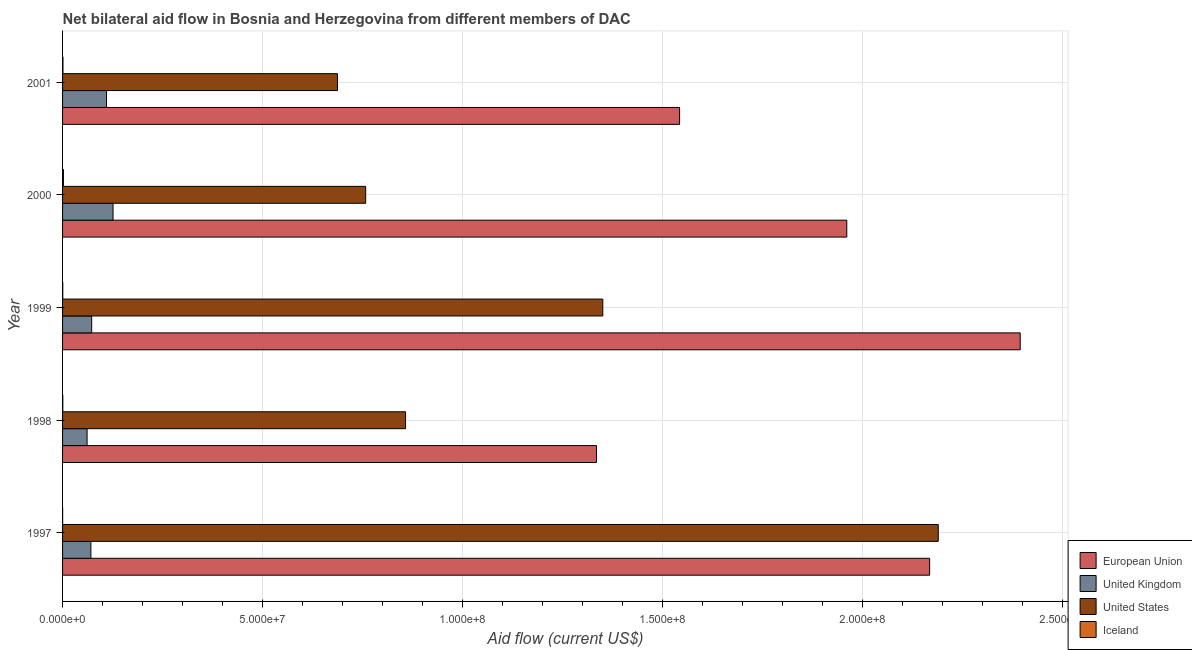How many different coloured bars are there?
Provide a short and direct response. 4. Are the number of bars per tick equal to the number of legend labels?
Offer a very short reply. Yes. Are the number of bars on each tick of the Y-axis equal?
Your response must be concise. Yes. How many bars are there on the 2nd tick from the top?
Provide a short and direct response. 4. How many bars are there on the 5th tick from the bottom?
Give a very brief answer. 4. In how many cases, is the number of bars for a given year not equal to the number of legend labels?
Ensure brevity in your answer.  0. What is the amount of aid given by eu in 1998?
Your answer should be compact. 1.33e+08. Across all years, what is the maximum amount of aid given by eu?
Keep it short and to the point. 2.39e+08. Across all years, what is the minimum amount of aid given by us?
Make the answer very short. 6.87e+07. What is the total amount of aid given by eu in the graph?
Offer a terse response. 9.40e+08. What is the difference between the amount of aid given by iceland in 1998 and that in 2000?
Ensure brevity in your answer.  -1.60e+05. What is the difference between the amount of aid given by eu in 2000 and the amount of aid given by uk in 1998?
Offer a very short reply. 1.90e+08. What is the average amount of aid given by us per year?
Your answer should be compact. 1.17e+08. In the year 1999, what is the difference between the amount of aid given by iceland and amount of aid given by eu?
Offer a terse response. -2.39e+08. What is the ratio of the amount of aid given by uk in 1999 to that in 2001?
Offer a very short reply. 0.66. Is the amount of aid given by uk in 1999 less than that in 2000?
Ensure brevity in your answer.  Yes. Is the difference between the amount of aid given by iceland in 1999 and 2000 greater than the difference between the amount of aid given by us in 1999 and 2000?
Your answer should be very brief. No. What is the difference between the highest and the lowest amount of aid given by eu?
Your answer should be compact. 1.06e+08. In how many years, is the amount of aid given by uk greater than the average amount of aid given by uk taken over all years?
Provide a succinct answer. 2. Is the sum of the amount of aid given by us in 1997 and 2001 greater than the maximum amount of aid given by uk across all years?
Offer a terse response. Yes. What does the 3rd bar from the top in 1999 represents?
Provide a short and direct response. United Kingdom. What does the 1st bar from the bottom in 1999 represents?
Provide a short and direct response. European Union. Is it the case that in every year, the sum of the amount of aid given by eu and amount of aid given by uk is greater than the amount of aid given by us?
Offer a terse response. Yes. Are all the bars in the graph horizontal?
Keep it short and to the point. Yes. Where does the legend appear in the graph?
Offer a terse response. Bottom right. How many legend labels are there?
Offer a terse response. 4. What is the title of the graph?
Your response must be concise. Net bilateral aid flow in Bosnia and Herzegovina from different members of DAC. What is the label or title of the X-axis?
Offer a very short reply. Aid flow (current US$). What is the label or title of the Y-axis?
Give a very brief answer. Year. What is the Aid flow (current US$) of European Union in 1997?
Your response must be concise. 2.17e+08. What is the Aid flow (current US$) in United Kingdom in 1997?
Make the answer very short. 7.08e+06. What is the Aid flow (current US$) in United States in 1997?
Provide a short and direct response. 2.19e+08. What is the Aid flow (current US$) of European Union in 1998?
Provide a short and direct response. 1.33e+08. What is the Aid flow (current US$) of United Kingdom in 1998?
Provide a short and direct response. 6.13e+06. What is the Aid flow (current US$) in United States in 1998?
Your answer should be very brief. 8.58e+07. What is the Aid flow (current US$) in Iceland in 1998?
Provide a short and direct response. 6.00e+04. What is the Aid flow (current US$) of European Union in 1999?
Your response must be concise. 2.39e+08. What is the Aid flow (current US$) of United Kingdom in 1999?
Your answer should be compact. 7.28e+06. What is the Aid flow (current US$) of United States in 1999?
Offer a very short reply. 1.35e+08. What is the Aid flow (current US$) of Iceland in 1999?
Offer a very short reply. 5.00e+04. What is the Aid flow (current US$) in European Union in 2000?
Ensure brevity in your answer.  1.96e+08. What is the Aid flow (current US$) in United Kingdom in 2000?
Make the answer very short. 1.26e+07. What is the Aid flow (current US$) in United States in 2000?
Offer a terse response. 7.58e+07. What is the Aid flow (current US$) of Iceland in 2000?
Give a very brief answer. 2.20e+05. What is the Aid flow (current US$) in European Union in 2001?
Make the answer very short. 1.54e+08. What is the Aid flow (current US$) in United Kingdom in 2001?
Keep it short and to the point. 1.10e+07. What is the Aid flow (current US$) in United States in 2001?
Offer a terse response. 6.87e+07. What is the Aid flow (current US$) of Iceland in 2001?
Provide a succinct answer. 1.00e+05. Across all years, what is the maximum Aid flow (current US$) of European Union?
Provide a succinct answer. 2.39e+08. Across all years, what is the maximum Aid flow (current US$) in United Kingdom?
Make the answer very short. 1.26e+07. Across all years, what is the maximum Aid flow (current US$) in United States?
Offer a terse response. 2.19e+08. Across all years, what is the maximum Aid flow (current US$) in Iceland?
Ensure brevity in your answer.  2.20e+05. Across all years, what is the minimum Aid flow (current US$) of European Union?
Your answer should be compact. 1.33e+08. Across all years, what is the minimum Aid flow (current US$) in United Kingdom?
Make the answer very short. 6.13e+06. Across all years, what is the minimum Aid flow (current US$) of United States?
Your answer should be compact. 6.87e+07. What is the total Aid flow (current US$) in European Union in the graph?
Your response must be concise. 9.40e+08. What is the total Aid flow (current US$) of United Kingdom in the graph?
Offer a terse response. 4.41e+07. What is the total Aid flow (current US$) in United States in the graph?
Provide a succinct answer. 5.84e+08. What is the total Aid flow (current US$) of Iceland in the graph?
Provide a succinct answer. 4.50e+05. What is the difference between the Aid flow (current US$) in European Union in 1997 and that in 1998?
Your answer should be very brief. 8.33e+07. What is the difference between the Aid flow (current US$) in United Kingdom in 1997 and that in 1998?
Ensure brevity in your answer.  9.50e+05. What is the difference between the Aid flow (current US$) in United States in 1997 and that in 1998?
Ensure brevity in your answer.  1.33e+08. What is the difference between the Aid flow (current US$) of Iceland in 1997 and that in 1998?
Give a very brief answer. -4.00e+04. What is the difference between the Aid flow (current US$) of European Union in 1997 and that in 1999?
Your response must be concise. -2.26e+07. What is the difference between the Aid flow (current US$) of United Kingdom in 1997 and that in 1999?
Your response must be concise. -2.00e+05. What is the difference between the Aid flow (current US$) in United States in 1997 and that in 1999?
Offer a very short reply. 8.39e+07. What is the difference between the Aid flow (current US$) of Iceland in 1997 and that in 1999?
Your answer should be very brief. -3.00e+04. What is the difference between the Aid flow (current US$) of European Union in 1997 and that in 2000?
Your answer should be very brief. 2.07e+07. What is the difference between the Aid flow (current US$) of United Kingdom in 1997 and that in 2000?
Ensure brevity in your answer.  -5.54e+06. What is the difference between the Aid flow (current US$) in United States in 1997 and that in 2000?
Give a very brief answer. 1.43e+08. What is the difference between the Aid flow (current US$) of European Union in 1997 and that in 2001?
Ensure brevity in your answer.  6.25e+07. What is the difference between the Aid flow (current US$) in United Kingdom in 1997 and that in 2001?
Give a very brief answer. -3.90e+06. What is the difference between the Aid flow (current US$) in United States in 1997 and that in 2001?
Keep it short and to the point. 1.50e+08. What is the difference between the Aid flow (current US$) of European Union in 1998 and that in 1999?
Provide a succinct answer. -1.06e+08. What is the difference between the Aid flow (current US$) of United Kingdom in 1998 and that in 1999?
Your answer should be very brief. -1.15e+06. What is the difference between the Aid flow (current US$) in United States in 1998 and that in 1999?
Offer a very short reply. -4.93e+07. What is the difference between the Aid flow (current US$) of European Union in 1998 and that in 2000?
Ensure brevity in your answer.  -6.26e+07. What is the difference between the Aid flow (current US$) in United Kingdom in 1998 and that in 2000?
Ensure brevity in your answer.  -6.49e+06. What is the difference between the Aid flow (current US$) of United States in 1998 and that in 2000?
Provide a succinct answer. 9.97e+06. What is the difference between the Aid flow (current US$) in Iceland in 1998 and that in 2000?
Your response must be concise. -1.60e+05. What is the difference between the Aid flow (current US$) in European Union in 1998 and that in 2001?
Make the answer very short. -2.08e+07. What is the difference between the Aid flow (current US$) in United Kingdom in 1998 and that in 2001?
Your response must be concise. -4.85e+06. What is the difference between the Aid flow (current US$) in United States in 1998 and that in 2001?
Give a very brief answer. 1.70e+07. What is the difference between the Aid flow (current US$) of European Union in 1999 and that in 2000?
Ensure brevity in your answer.  4.34e+07. What is the difference between the Aid flow (current US$) of United Kingdom in 1999 and that in 2000?
Ensure brevity in your answer.  -5.34e+06. What is the difference between the Aid flow (current US$) of United States in 1999 and that in 2000?
Offer a very short reply. 5.93e+07. What is the difference between the Aid flow (current US$) in Iceland in 1999 and that in 2000?
Your answer should be very brief. -1.70e+05. What is the difference between the Aid flow (current US$) in European Union in 1999 and that in 2001?
Provide a short and direct response. 8.52e+07. What is the difference between the Aid flow (current US$) in United Kingdom in 1999 and that in 2001?
Provide a short and direct response. -3.70e+06. What is the difference between the Aid flow (current US$) of United States in 1999 and that in 2001?
Provide a short and direct response. 6.63e+07. What is the difference between the Aid flow (current US$) in European Union in 2000 and that in 2001?
Offer a very short reply. 4.18e+07. What is the difference between the Aid flow (current US$) in United Kingdom in 2000 and that in 2001?
Provide a short and direct response. 1.64e+06. What is the difference between the Aid flow (current US$) in United States in 2000 and that in 2001?
Offer a terse response. 7.04e+06. What is the difference between the Aid flow (current US$) in European Union in 1997 and the Aid flow (current US$) in United Kingdom in 1998?
Your response must be concise. 2.11e+08. What is the difference between the Aid flow (current US$) in European Union in 1997 and the Aid flow (current US$) in United States in 1998?
Your response must be concise. 1.31e+08. What is the difference between the Aid flow (current US$) of European Union in 1997 and the Aid flow (current US$) of Iceland in 1998?
Offer a very short reply. 2.17e+08. What is the difference between the Aid flow (current US$) of United Kingdom in 1997 and the Aid flow (current US$) of United States in 1998?
Ensure brevity in your answer.  -7.87e+07. What is the difference between the Aid flow (current US$) of United Kingdom in 1997 and the Aid flow (current US$) of Iceland in 1998?
Your answer should be very brief. 7.02e+06. What is the difference between the Aid flow (current US$) of United States in 1997 and the Aid flow (current US$) of Iceland in 1998?
Offer a terse response. 2.19e+08. What is the difference between the Aid flow (current US$) of European Union in 1997 and the Aid flow (current US$) of United Kingdom in 1999?
Make the answer very short. 2.09e+08. What is the difference between the Aid flow (current US$) of European Union in 1997 and the Aid flow (current US$) of United States in 1999?
Offer a very short reply. 8.17e+07. What is the difference between the Aid flow (current US$) of European Union in 1997 and the Aid flow (current US$) of Iceland in 1999?
Ensure brevity in your answer.  2.17e+08. What is the difference between the Aid flow (current US$) of United Kingdom in 1997 and the Aid flow (current US$) of United States in 1999?
Your answer should be compact. -1.28e+08. What is the difference between the Aid flow (current US$) of United Kingdom in 1997 and the Aid flow (current US$) of Iceland in 1999?
Your response must be concise. 7.03e+06. What is the difference between the Aid flow (current US$) of United States in 1997 and the Aid flow (current US$) of Iceland in 1999?
Provide a short and direct response. 2.19e+08. What is the difference between the Aid flow (current US$) in European Union in 1997 and the Aid flow (current US$) in United Kingdom in 2000?
Offer a terse response. 2.04e+08. What is the difference between the Aid flow (current US$) in European Union in 1997 and the Aid flow (current US$) in United States in 2000?
Your answer should be very brief. 1.41e+08. What is the difference between the Aid flow (current US$) of European Union in 1997 and the Aid flow (current US$) of Iceland in 2000?
Provide a short and direct response. 2.17e+08. What is the difference between the Aid flow (current US$) of United Kingdom in 1997 and the Aid flow (current US$) of United States in 2000?
Make the answer very short. -6.87e+07. What is the difference between the Aid flow (current US$) in United Kingdom in 1997 and the Aid flow (current US$) in Iceland in 2000?
Provide a succinct answer. 6.86e+06. What is the difference between the Aid flow (current US$) in United States in 1997 and the Aid flow (current US$) in Iceland in 2000?
Provide a succinct answer. 2.19e+08. What is the difference between the Aid flow (current US$) in European Union in 1997 and the Aid flow (current US$) in United Kingdom in 2001?
Provide a short and direct response. 2.06e+08. What is the difference between the Aid flow (current US$) in European Union in 1997 and the Aid flow (current US$) in United States in 2001?
Provide a short and direct response. 1.48e+08. What is the difference between the Aid flow (current US$) in European Union in 1997 and the Aid flow (current US$) in Iceland in 2001?
Offer a terse response. 2.17e+08. What is the difference between the Aid flow (current US$) in United Kingdom in 1997 and the Aid flow (current US$) in United States in 2001?
Ensure brevity in your answer.  -6.17e+07. What is the difference between the Aid flow (current US$) of United Kingdom in 1997 and the Aid flow (current US$) of Iceland in 2001?
Your answer should be very brief. 6.98e+06. What is the difference between the Aid flow (current US$) in United States in 1997 and the Aid flow (current US$) in Iceland in 2001?
Give a very brief answer. 2.19e+08. What is the difference between the Aid flow (current US$) of European Union in 1998 and the Aid flow (current US$) of United Kingdom in 1999?
Give a very brief answer. 1.26e+08. What is the difference between the Aid flow (current US$) in European Union in 1998 and the Aid flow (current US$) in United States in 1999?
Provide a succinct answer. -1.57e+06. What is the difference between the Aid flow (current US$) of European Union in 1998 and the Aid flow (current US$) of Iceland in 1999?
Make the answer very short. 1.33e+08. What is the difference between the Aid flow (current US$) of United Kingdom in 1998 and the Aid flow (current US$) of United States in 1999?
Offer a very short reply. -1.29e+08. What is the difference between the Aid flow (current US$) of United Kingdom in 1998 and the Aid flow (current US$) of Iceland in 1999?
Your answer should be compact. 6.08e+06. What is the difference between the Aid flow (current US$) of United States in 1998 and the Aid flow (current US$) of Iceland in 1999?
Give a very brief answer. 8.57e+07. What is the difference between the Aid flow (current US$) in European Union in 1998 and the Aid flow (current US$) in United Kingdom in 2000?
Give a very brief answer. 1.21e+08. What is the difference between the Aid flow (current US$) of European Union in 1998 and the Aid flow (current US$) of United States in 2000?
Make the answer very short. 5.77e+07. What is the difference between the Aid flow (current US$) of European Union in 1998 and the Aid flow (current US$) of Iceland in 2000?
Offer a terse response. 1.33e+08. What is the difference between the Aid flow (current US$) of United Kingdom in 1998 and the Aid flow (current US$) of United States in 2000?
Make the answer very short. -6.96e+07. What is the difference between the Aid flow (current US$) in United Kingdom in 1998 and the Aid flow (current US$) in Iceland in 2000?
Your response must be concise. 5.91e+06. What is the difference between the Aid flow (current US$) of United States in 1998 and the Aid flow (current US$) of Iceland in 2000?
Give a very brief answer. 8.55e+07. What is the difference between the Aid flow (current US$) in European Union in 1998 and the Aid flow (current US$) in United Kingdom in 2001?
Provide a short and direct response. 1.23e+08. What is the difference between the Aid flow (current US$) in European Union in 1998 and the Aid flow (current US$) in United States in 2001?
Your answer should be very brief. 6.48e+07. What is the difference between the Aid flow (current US$) in European Union in 1998 and the Aid flow (current US$) in Iceland in 2001?
Your answer should be compact. 1.33e+08. What is the difference between the Aid flow (current US$) in United Kingdom in 1998 and the Aid flow (current US$) in United States in 2001?
Your answer should be very brief. -6.26e+07. What is the difference between the Aid flow (current US$) of United Kingdom in 1998 and the Aid flow (current US$) of Iceland in 2001?
Your answer should be compact. 6.03e+06. What is the difference between the Aid flow (current US$) of United States in 1998 and the Aid flow (current US$) of Iceland in 2001?
Keep it short and to the point. 8.56e+07. What is the difference between the Aid flow (current US$) in European Union in 1999 and the Aid flow (current US$) in United Kingdom in 2000?
Keep it short and to the point. 2.27e+08. What is the difference between the Aid flow (current US$) in European Union in 1999 and the Aid flow (current US$) in United States in 2000?
Your answer should be very brief. 1.64e+08. What is the difference between the Aid flow (current US$) in European Union in 1999 and the Aid flow (current US$) in Iceland in 2000?
Provide a succinct answer. 2.39e+08. What is the difference between the Aid flow (current US$) in United Kingdom in 1999 and the Aid flow (current US$) in United States in 2000?
Keep it short and to the point. -6.85e+07. What is the difference between the Aid flow (current US$) in United Kingdom in 1999 and the Aid flow (current US$) in Iceland in 2000?
Offer a terse response. 7.06e+06. What is the difference between the Aid flow (current US$) in United States in 1999 and the Aid flow (current US$) in Iceland in 2000?
Your answer should be very brief. 1.35e+08. What is the difference between the Aid flow (current US$) of European Union in 1999 and the Aid flow (current US$) of United Kingdom in 2001?
Your answer should be compact. 2.28e+08. What is the difference between the Aid flow (current US$) in European Union in 1999 and the Aid flow (current US$) in United States in 2001?
Ensure brevity in your answer.  1.71e+08. What is the difference between the Aid flow (current US$) in European Union in 1999 and the Aid flow (current US$) in Iceland in 2001?
Ensure brevity in your answer.  2.39e+08. What is the difference between the Aid flow (current US$) in United Kingdom in 1999 and the Aid flow (current US$) in United States in 2001?
Keep it short and to the point. -6.15e+07. What is the difference between the Aid flow (current US$) of United Kingdom in 1999 and the Aid flow (current US$) of Iceland in 2001?
Your response must be concise. 7.18e+06. What is the difference between the Aid flow (current US$) of United States in 1999 and the Aid flow (current US$) of Iceland in 2001?
Give a very brief answer. 1.35e+08. What is the difference between the Aid flow (current US$) in European Union in 2000 and the Aid flow (current US$) in United Kingdom in 2001?
Your answer should be compact. 1.85e+08. What is the difference between the Aid flow (current US$) of European Union in 2000 and the Aid flow (current US$) of United States in 2001?
Your answer should be compact. 1.27e+08. What is the difference between the Aid flow (current US$) in European Union in 2000 and the Aid flow (current US$) in Iceland in 2001?
Give a very brief answer. 1.96e+08. What is the difference between the Aid flow (current US$) in United Kingdom in 2000 and the Aid flow (current US$) in United States in 2001?
Offer a very short reply. -5.61e+07. What is the difference between the Aid flow (current US$) in United Kingdom in 2000 and the Aid flow (current US$) in Iceland in 2001?
Provide a short and direct response. 1.25e+07. What is the difference between the Aid flow (current US$) of United States in 2000 and the Aid flow (current US$) of Iceland in 2001?
Your response must be concise. 7.57e+07. What is the average Aid flow (current US$) in European Union per year?
Your answer should be very brief. 1.88e+08. What is the average Aid flow (current US$) in United Kingdom per year?
Keep it short and to the point. 8.82e+06. What is the average Aid flow (current US$) of United States per year?
Ensure brevity in your answer.  1.17e+08. In the year 1997, what is the difference between the Aid flow (current US$) of European Union and Aid flow (current US$) of United Kingdom?
Keep it short and to the point. 2.10e+08. In the year 1997, what is the difference between the Aid flow (current US$) in European Union and Aid flow (current US$) in United States?
Keep it short and to the point. -2.16e+06. In the year 1997, what is the difference between the Aid flow (current US$) of European Union and Aid flow (current US$) of Iceland?
Provide a short and direct response. 2.17e+08. In the year 1997, what is the difference between the Aid flow (current US$) of United Kingdom and Aid flow (current US$) of United States?
Offer a terse response. -2.12e+08. In the year 1997, what is the difference between the Aid flow (current US$) in United Kingdom and Aid flow (current US$) in Iceland?
Your answer should be compact. 7.06e+06. In the year 1997, what is the difference between the Aid flow (current US$) in United States and Aid flow (current US$) in Iceland?
Provide a succinct answer. 2.19e+08. In the year 1998, what is the difference between the Aid flow (current US$) of European Union and Aid flow (current US$) of United Kingdom?
Ensure brevity in your answer.  1.27e+08. In the year 1998, what is the difference between the Aid flow (current US$) of European Union and Aid flow (current US$) of United States?
Provide a succinct answer. 4.77e+07. In the year 1998, what is the difference between the Aid flow (current US$) in European Union and Aid flow (current US$) in Iceland?
Offer a terse response. 1.33e+08. In the year 1998, what is the difference between the Aid flow (current US$) in United Kingdom and Aid flow (current US$) in United States?
Offer a terse response. -7.96e+07. In the year 1998, what is the difference between the Aid flow (current US$) in United Kingdom and Aid flow (current US$) in Iceland?
Your response must be concise. 6.07e+06. In the year 1998, what is the difference between the Aid flow (current US$) in United States and Aid flow (current US$) in Iceland?
Your answer should be very brief. 8.57e+07. In the year 1999, what is the difference between the Aid flow (current US$) in European Union and Aid flow (current US$) in United Kingdom?
Your answer should be compact. 2.32e+08. In the year 1999, what is the difference between the Aid flow (current US$) of European Union and Aid flow (current US$) of United States?
Give a very brief answer. 1.04e+08. In the year 1999, what is the difference between the Aid flow (current US$) of European Union and Aid flow (current US$) of Iceland?
Offer a very short reply. 2.39e+08. In the year 1999, what is the difference between the Aid flow (current US$) of United Kingdom and Aid flow (current US$) of United States?
Your answer should be compact. -1.28e+08. In the year 1999, what is the difference between the Aid flow (current US$) in United Kingdom and Aid flow (current US$) in Iceland?
Your response must be concise. 7.23e+06. In the year 1999, what is the difference between the Aid flow (current US$) in United States and Aid flow (current US$) in Iceland?
Offer a terse response. 1.35e+08. In the year 2000, what is the difference between the Aid flow (current US$) in European Union and Aid flow (current US$) in United Kingdom?
Keep it short and to the point. 1.83e+08. In the year 2000, what is the difference between the Aid flow (current US$) of European Union and Aid flow (current US$) of United States?
Your answer should be very brief. 1.20e+08. In the year 2000, what is the difference between the Aid flow (current US$) in European Union and Aid flow (current US$) in Iceland?
Provide a succinct answer. 1.96e+08. In the year 2000, what is the difference between the Aid flow (current US$) of United Kingdom and Aid flow (current US$) of United States?
Offer a very short reply. -6.32e+07. In the year 2000, what is the difference between the Aid flow (current US$) in United Kingdom and Aid flow (current US$) in Iceland?
Offer a terse response. 1.24e+07. In the year 2000, what is the difference between the Aid flow (current US$) in United States and Aid flow (current US$) in Iceland?
Offer a very short reply. 7.56e+07. In the year 2001, what is the difference between the Aid flow (current US$) in European Union and Aid flow (current US$) in United Kingdom?
Keep it short and to the point. 1.43e+08. In the year 2001, what is the difference between the Aid flow (current US$) of European Union and Aid flow (current US$) of United States?
Your answer should be very brief. 8.55e+07. In the year 2001, what is the difference between the Aid flow (current US$) in European Union and Aid flow (current US$) in Iceland?
Provide a succinct answer. 1.54e+08. In the year 2001, what is the difference between the Aid flow (current US$) of United Kingdom and Aid flow (current US$) of United States?
Provide a short and direct response. -5.78e+07. In the year 2001, what is the difference between the Aid flow (current US$) of United Kingdom and Aid flow (current US$) of Iceland?
Your answer should be very brief. 1.09e+07. In the year 2001, what is the difference between the Aid flow (current US$) of United States and Aid flow (current US$) of Iceland?
Offer a terse response. 6.86e+07. What is the ratio of the Aid flow (current US$) of European Union in 1997 to that in 1998?
Provide a succinct answer. 1.62. What is the ratio of the Aid flow (current US$) of United Kingdom in 1997 to that in 1998?
Keep it short and to the point. 1.16. What is the ratio of the Aid flow (current US$) of United States in 1997 to that in 1998?
Your answer should be compact. 2.55. What is the ratio of the Aid flow (current US$) in European Union in 1997 to that in 1999?
Make the answer very short. 0.91. What is the ratio of the Aid flow (current US$) of United Kingdom in 1997 to that in 1999?
Keep it short and to the point. 0.97. What is the ratio of the Aid flow (current US$) of United States in 1997 to that in 1999?
Keep it short and to the point. 1.62. What is the ratio of the Aid flow (current US$) in Iceland in 1997 to that in 1999?
Provide a short and direct response. 0.4. What is the ratio of the Aid flow (current US$) of European Union in 1997 to that in 2000?
Keep it short and to the point. 1.11. What is the ratio of the Aid flow (current US$) of United Kingdom in 1997 to that in 2000?
Your answer should be very brief. 0.56. What is the ratio of the Aid flow (current US$) in United States in 1997 to that in 2000?
Your answer should be compact. 2.89. What is the ratio of the Aid flow (current US$) in Iceland in 1997 to that in 2000?
Ensure brevity in your answer.  0.09. What is the ratio of the Aid flow (current US$) of European Union in 1997 to that in 2001?
Provide a short and direct response. 1.41. What is the ratio of the Aid flow (current US$) in United Kingdom in 1997 to that in 2001?
Your answer should be compact. 0.64. What is the ratio of the Aid flow (current US$) in United States in 1997 to that in 2001?
Provide a short and direct response. 3.18. What is the ratio of the Aid flow (current US$) in European Union in 1998 to that in 1999?
Your answer should be compact. 0.56. What is the ratio of the Aid flow (current US$) of United Kingdom in 1998 to that in 1999?
Make the answer very short. 0.84. What is the ratio of the Aid flow (current US$) in United States in 1998 to that in 1999?
Provide a succinct answer. 0.63. What is the ratio of the Aid flow (current US$) of Iceland in 1998 to that in 1999?
Your response must be concise. 1.2. What is the ratio of the Aid flow (current US$) of European Union in 1998 to that in 2000?
Your answer should be compact. 0.68. What is the ratio of the Aid flow (current US$) in United Kingdom in 1998 to that in 2000?
Give a very brief answer. 0.49. What is the ratio of the Aid flow (current US$) in United States in 1998 to that in 2000?
Offer a terse response. 1.13. What is the ratio of the Aid flow (current US$) of Iceland in 1998 to that in 2000?
Ensure brevity in your answer.  0.27. What is the ratio of the Aid flow (current US$) of European Union in 1998 to that in 2001?
Offer a terse response. 0.87. What is the ratio of the Aid flow (current US$) in United Kingdom in 1998 to that in 2001?
Give a very brief answer. 0.56. What is the ratio of the Aid flow (current US$) of United States in 1998 to that in 2001?
Give a very brief answer. 1.25. What is the ratio of the Aid flow (current US$) in European Union in 1999 to that in 2000?
Offer a terse response. 1.22. What is the ratio of the Aid flow (current US$) of United Kingdom in 1999 to that in 2000?
Provide a succinct answer. 0.58. What is the ratio of the Aid flow (current US$) in United States in 1999 to that in 2000?
Your answer should be very brief. 1.78. What is the ratio of the Aid flow (current US$) in Iceland in 1999 to that in 2000?
Offer a very short reply. 0.23. What is the ratio of the Aid flow (current US$) in European Union in 1999 to that in 2001?
Give a very brief answer. 1.55. What is the ratio of the Aid flow (current US$) of United Kingdom in 1999 to that in 2001?
Ensure brevity in your answer.  0.66. What is the ratio of the Aid flow (current US$) of United States in 1999 to that in 2001?
Ensure brevity in your answer.  1.96. What is the ratio of the Aid flow (current US$) in European Union in 2000 to that in 2001?
Provide a succinct answer. 1.27. What is the ratio of the Aid flow (current US$) of United Kingdom in 2000 to that in 2001?
Provide a succinct answer. 1.15. What is the ratio of the Aid flow (current US$) in United States in 2000 to that in 2001?
Offer a terse response. 1.1. What is the ratio of the Aid flow (current US$) in Iceland in 2000 to that in 2001?
Your answer should be very brief. 2.2. What is the difference between the highest and the second highest Aid flow (current US$) of European Union?
Ensure brevity in your answer.  2.26e+07. What is the difference between the highest and the second highest Aid flow (current US$) of United Kingdom?
Your answer should be very brief. 1.64e+06. What is the difference between the highest and the second highest Aid flow (current US$) of United States?
Keep it short and to the point. 8.39e+07. What is the difference between the highest and the second highest Aid flow (current US$) in Iceland?
Give a very brief answer. 1.20e+05. What is the difference between the highest and the lowest Aid flow (current US$) in European Union?
Offer a very short reply. 1.06e+08. What is the difference between the highest and the lowest Aid flow (current US$) in United Kingdom?
Offer a terse response. 6.49e+06. What is the difference between the highest and the lowest Aid flow (current US$) of United States?
Keep it short and to the point. 1.50e+08. What is the difference between the highest and the lowest Aid flow (current US$) in Iceland?
Offer a very short reply. 2.00e+05. 